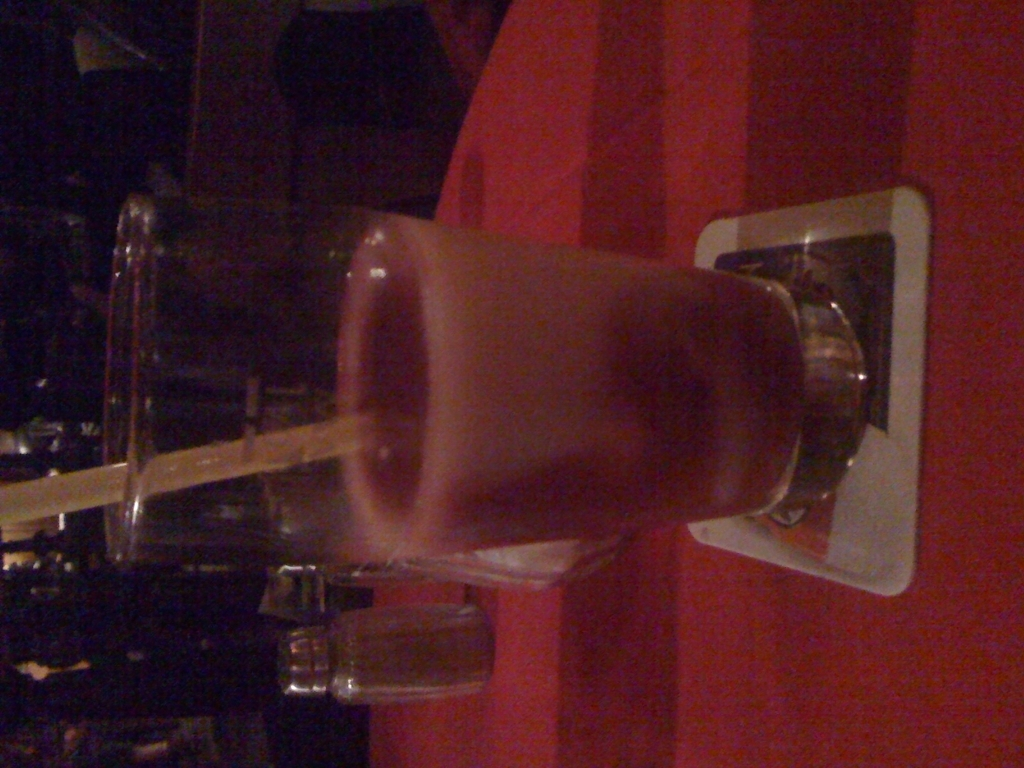What kind of drink is this and is it served in an appropriate glass? The drink appears to be a milkshake or a creamy cocktail, often served in a glass like the one shown. However, it's important to note that the content cannot be definitively identified without more context. The glass seems appropriate for thick, creamy drinks, providing enough room for the beverage and a straw. 